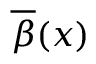Convert formula to latex. <formula><loc_0><loc_0><loc_500><loc_500>{ \overline { \beta } } ( x )</formula> 